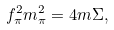Convert formula to latex. <formula><loc_0><loc_0><loc_500><loc_500>f _ { \pi } ^ { 2 } m _ { \pi } ^ { 2 } = 4 m \Sigma ,</formula> 